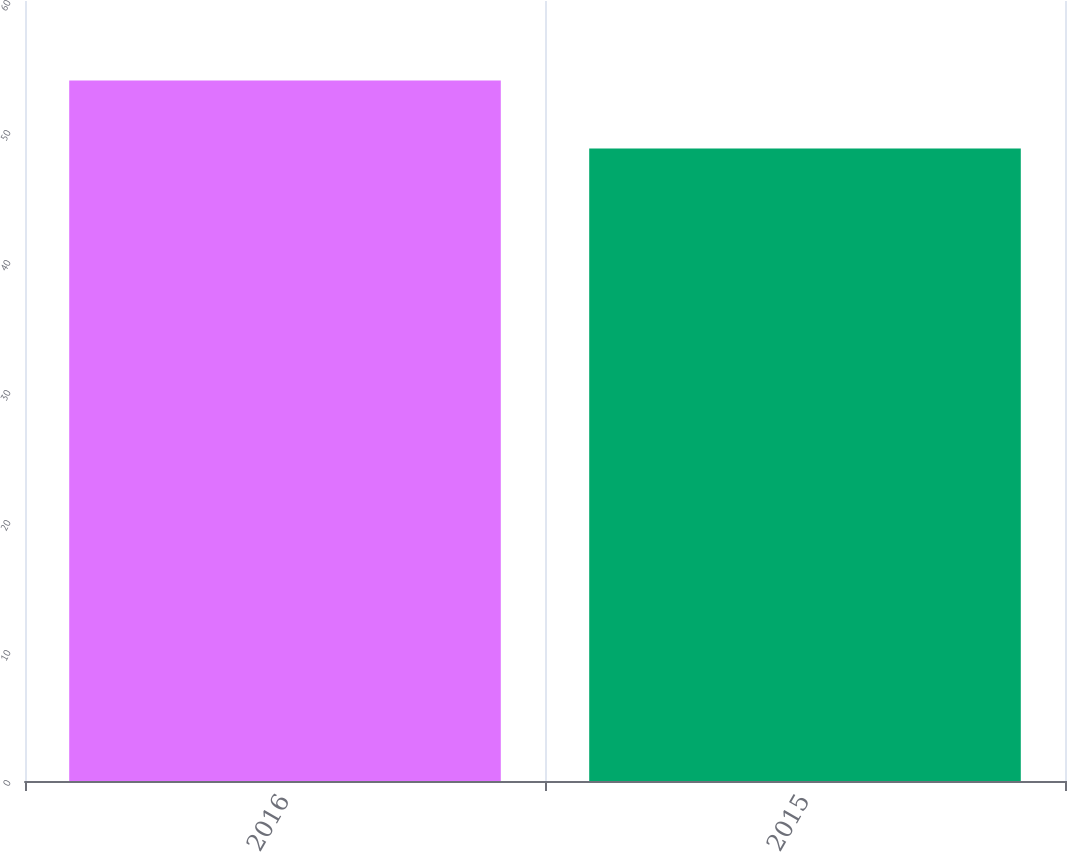Convert chart. <chart><loc_0><loc_0><loc_500><loc_500><bar_chart><fcel>2016<fcel>2015<nl><fcel>53.88<fcel>48.66<nl></chart> 